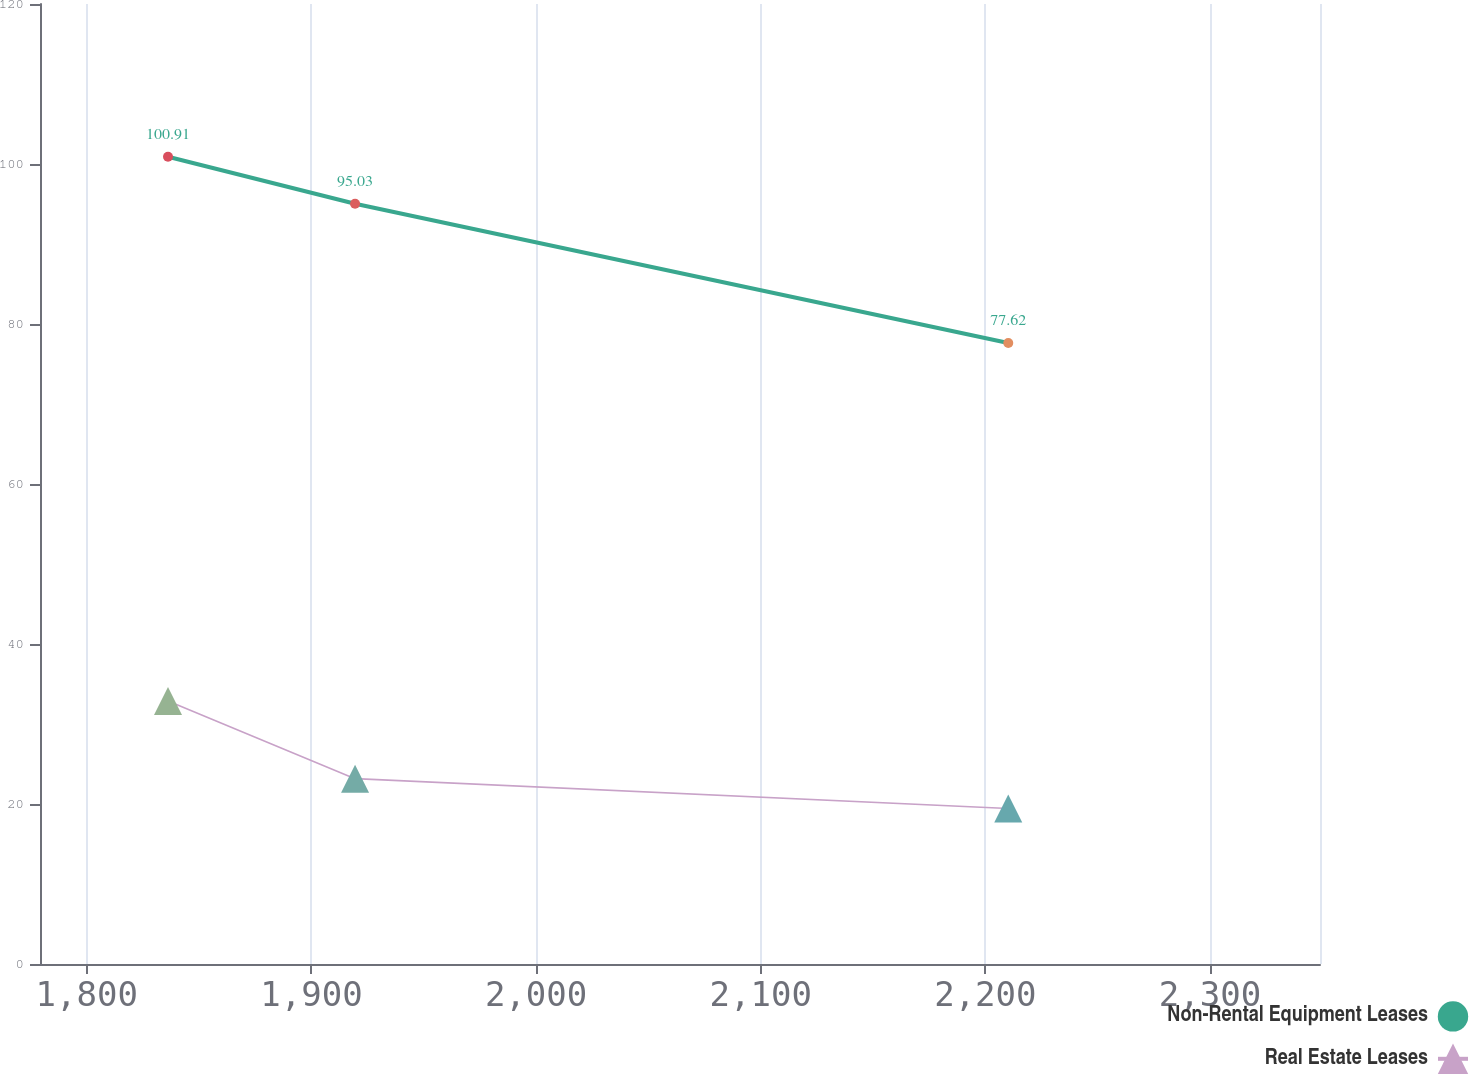<chart> <loc_0><loc_0><loc_500><loc_500><line_chart><ecel><fcel>Non-Rental Equipment Leases<fcel>Real Estate Leases<nl><fcel>1836.15<fcel>100.91<fcel>32.87<nl><fcel>1919.42<fcel>95.03<fcel>23.17<nl><fcel>2210.2<fcel>77.62<fcel>19.44<nl><fcel>2351.33<fcel>50.24<fcel>16.61<nl><fcel>2405.95<fcel>38.13<fcel>12.83<nl></chart> 